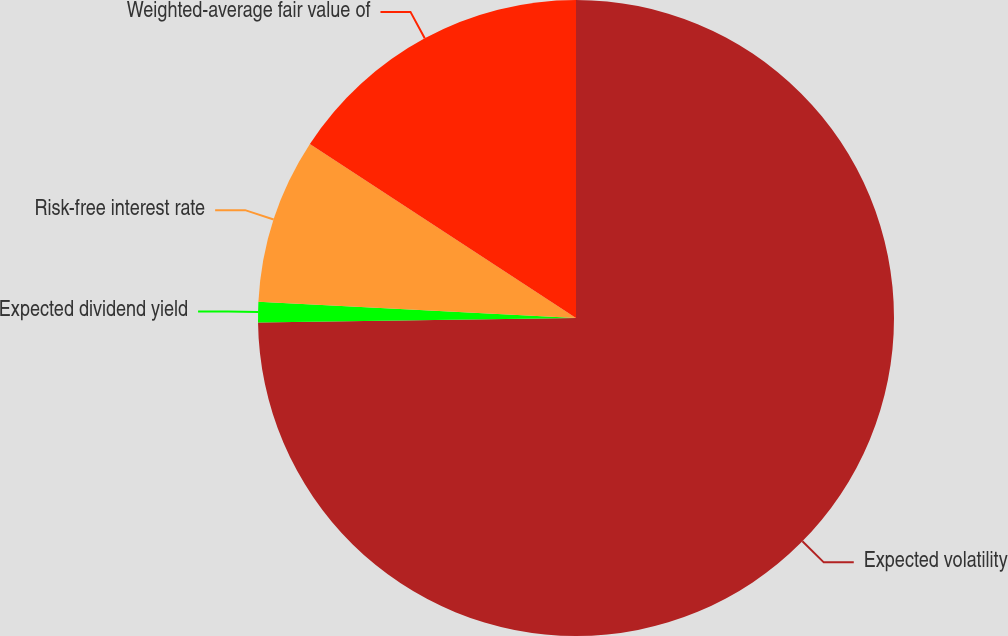Convert chart to OTSL. <chart><loc_0><loc_0><loc_500><loc_500><pie_chart><fcel>Expected volatility<fcel>Expected dividend yield<fcel>Risk-free interest rate<fcel>Weighted-average fair value of<nl><fcel>74.78%<fcel>1.03%<fcel>8.41%<fcel>15.78%<nl></chart> 